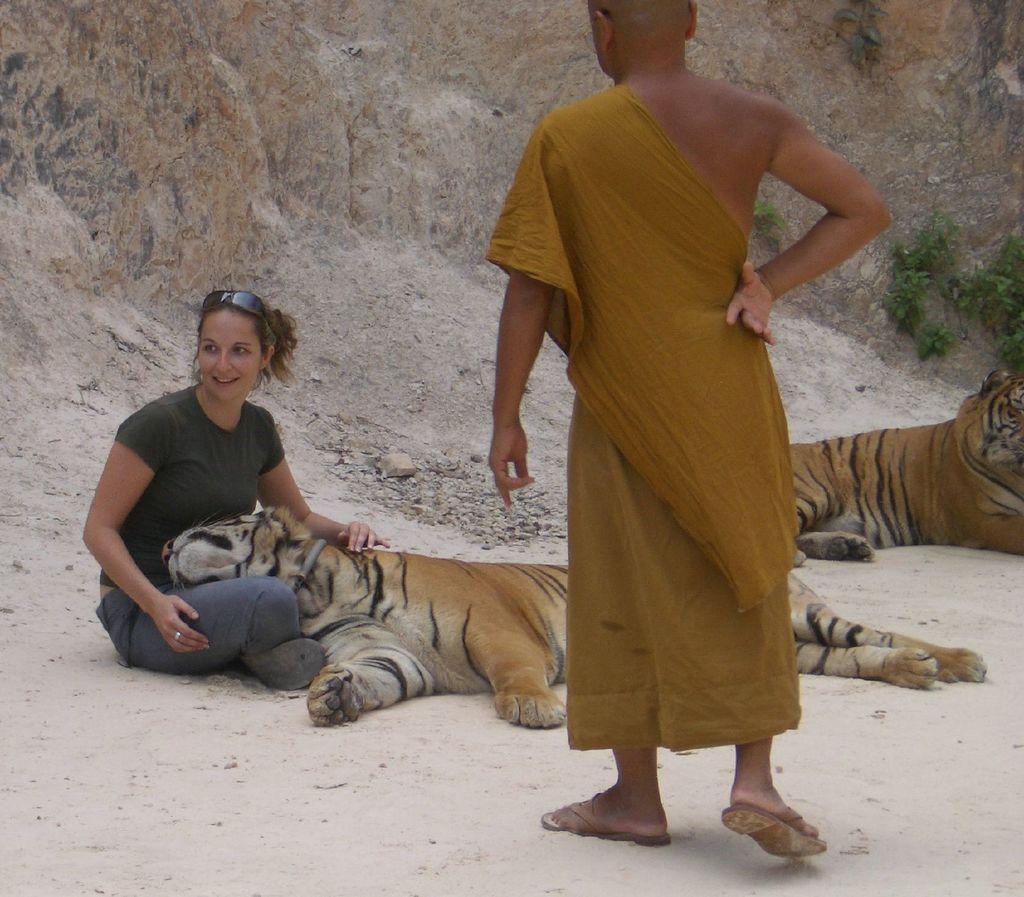Can you describe this image briefly? In this image we can see there is a person sitting on the ground and another person is standing. And there are animals. At the back there is a rock and plants. 